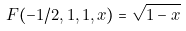<formula> <loc_0><loc_0><loc_500><loc_500>F ( - 1 / 2 , 1 , 1 , x ) = \sqrt { 1 - x }</formula> 